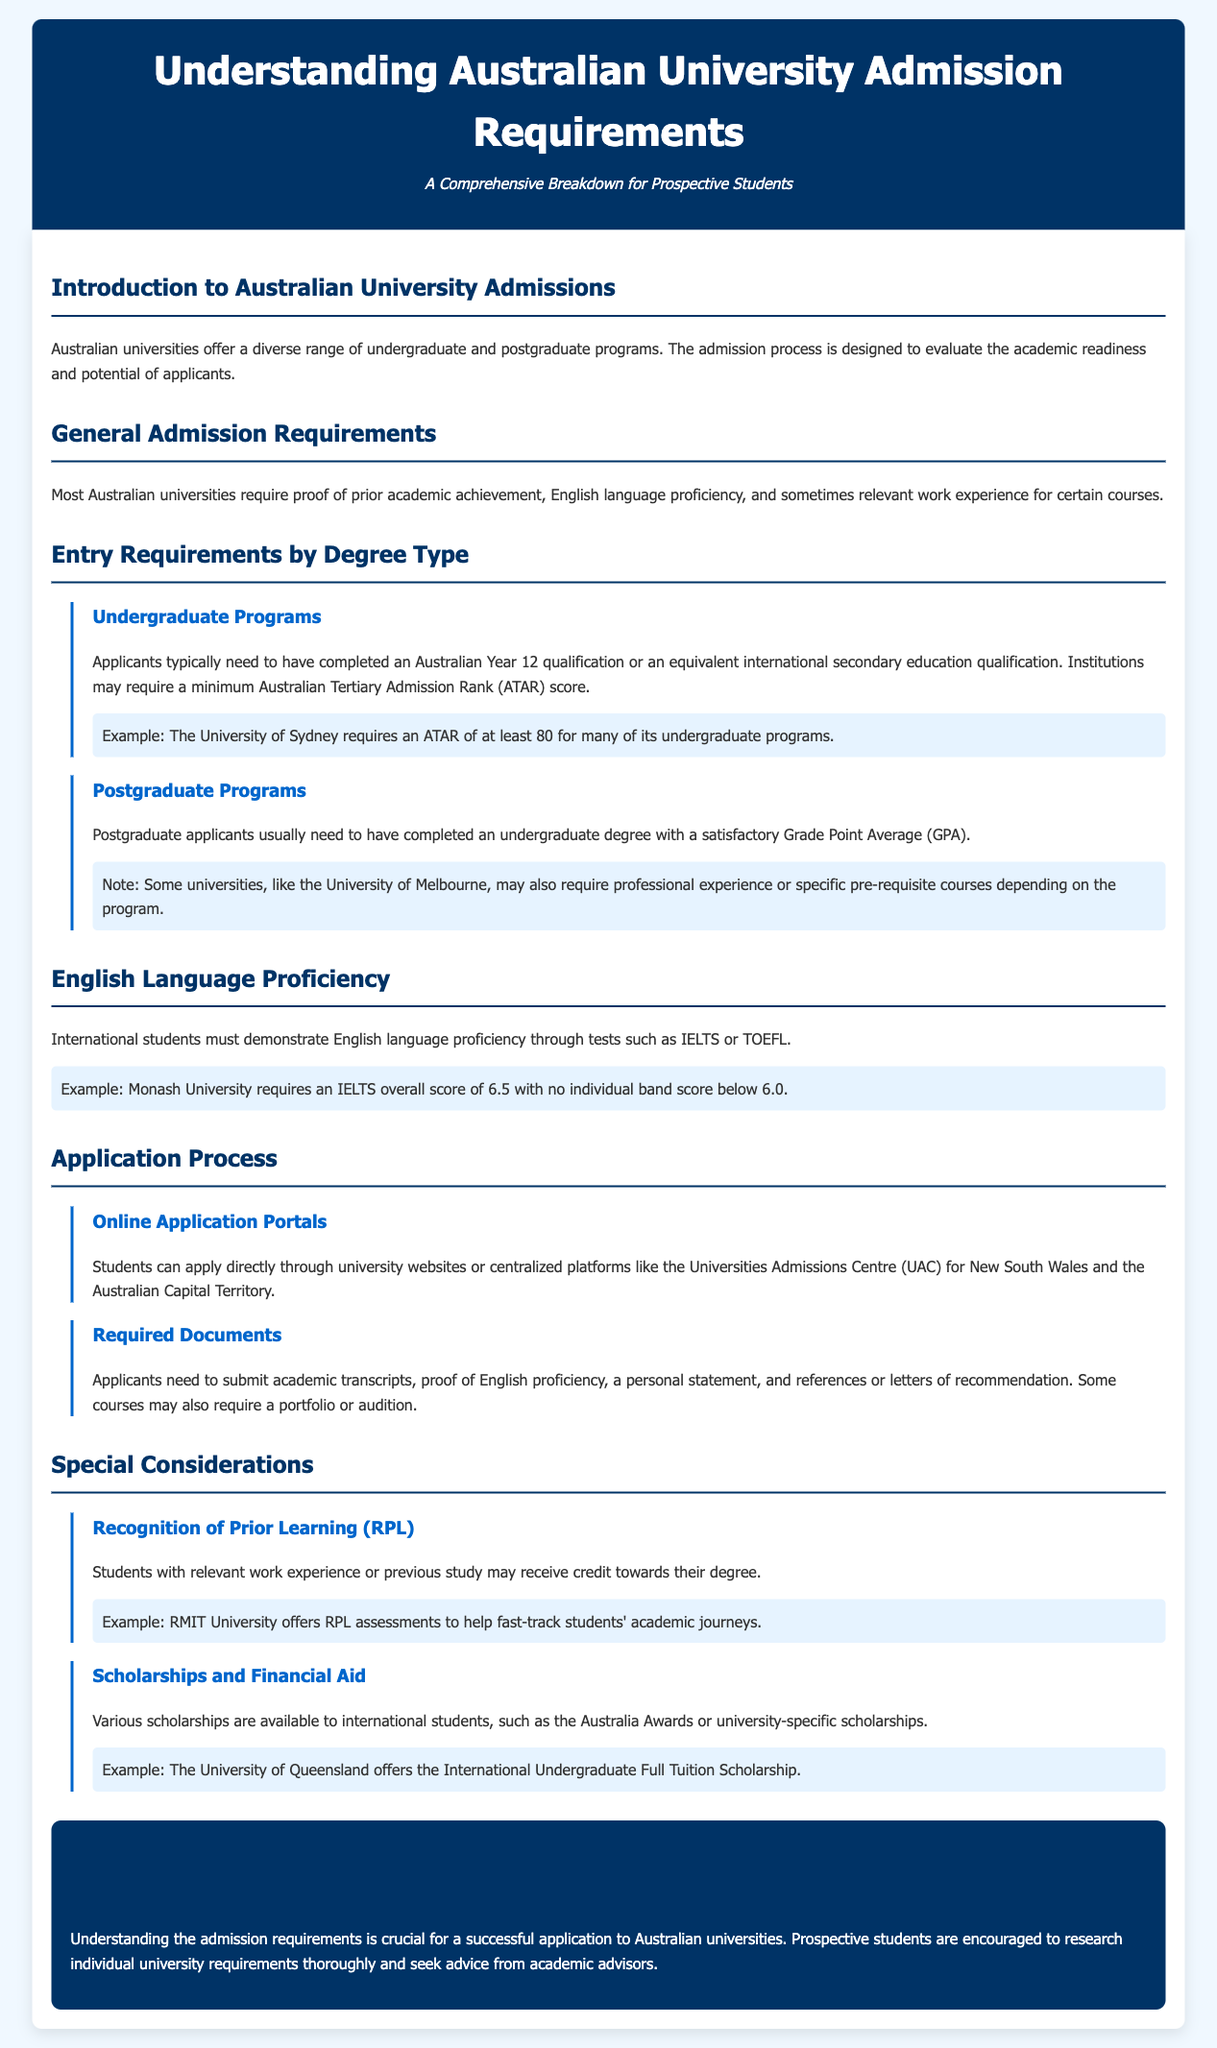What is the main purpose of the document? The document aims to provide a comprehensive breakdown of admission requirements for prospective students interested in Australian universities.
Answer: Comprehensive breakdown of admission requirements What is the minimum ATAR required by the University of Sydney? The document states that the University of Sydney requires an ATAR of at least 80 for many of its undergraduate programs.
Answer: 80 Which test is commonly used to assess English language proficiency? The document mentions that tests such as IELTS or TOEFL are used to demonstrate English language proficiency.
Answer: IELTS or TOEFL What type of scholarships are available to international students? The document lists various scholarships available, such as the Australia Awards or university-specific scholarships.
Answer: Australia Awards What is the required IELTS score for Monash University? Monash University requires an IELTS overall score of 6.5 with no individual band score below 6.0.
Answer: 6.5 What is one example of how prior learning can benefit a student? The document mentions that students with relevant work experience or previous study may receive credit towards their degree.
Answer: Credit towards their degree What must postgraduate applicants typically have completed? Postgraduate applicants usually need to have completed an undergraduate degree with a satisfactory Grade Point Average (GPA).
Answer: Undergraduate degree with satisfactory GPA What type of documents are required for the application process? Applicants need to submit academic transcripts, proof of English proficiency, a personal statement, and references.
Answer: Academic transcripts, proof of English proficiency, personal statement, and references 